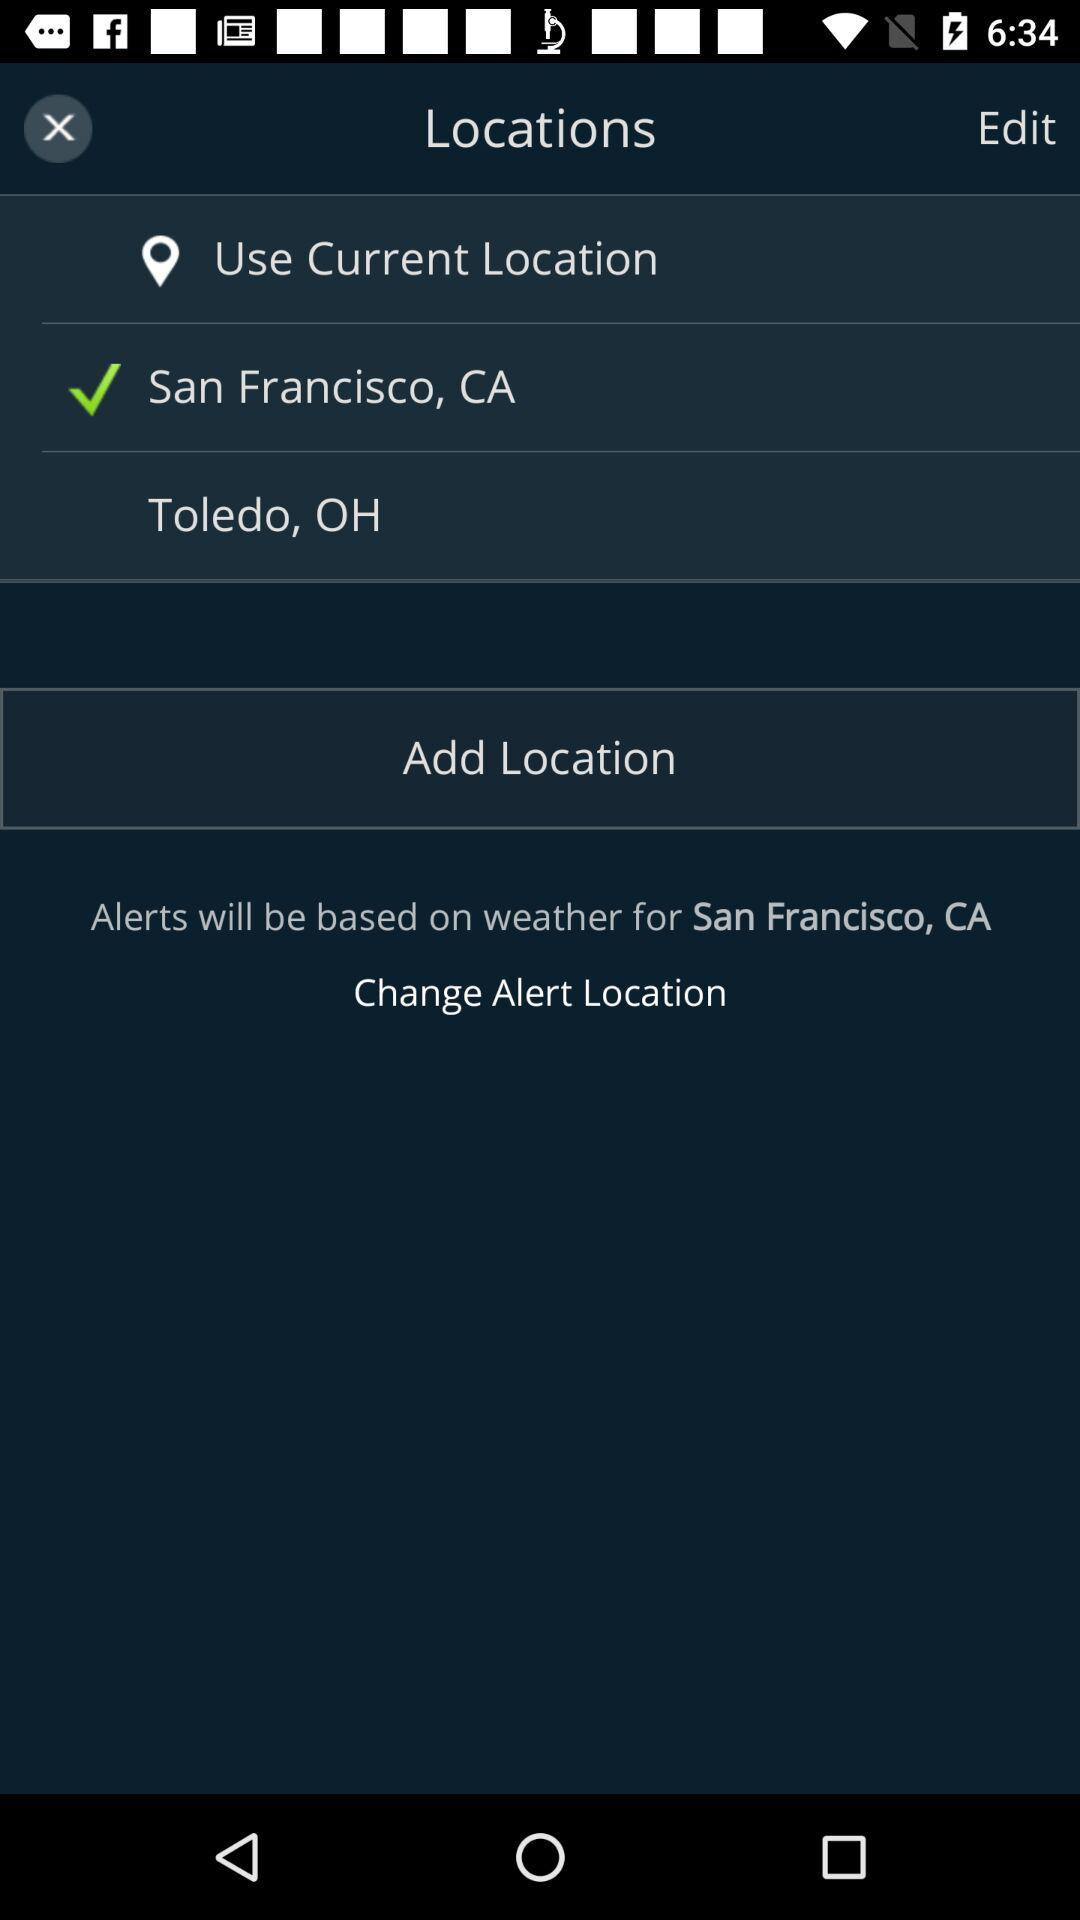On which location's weather will alerts be based? Alerts will be based on the weather in San Francisco, CA. 